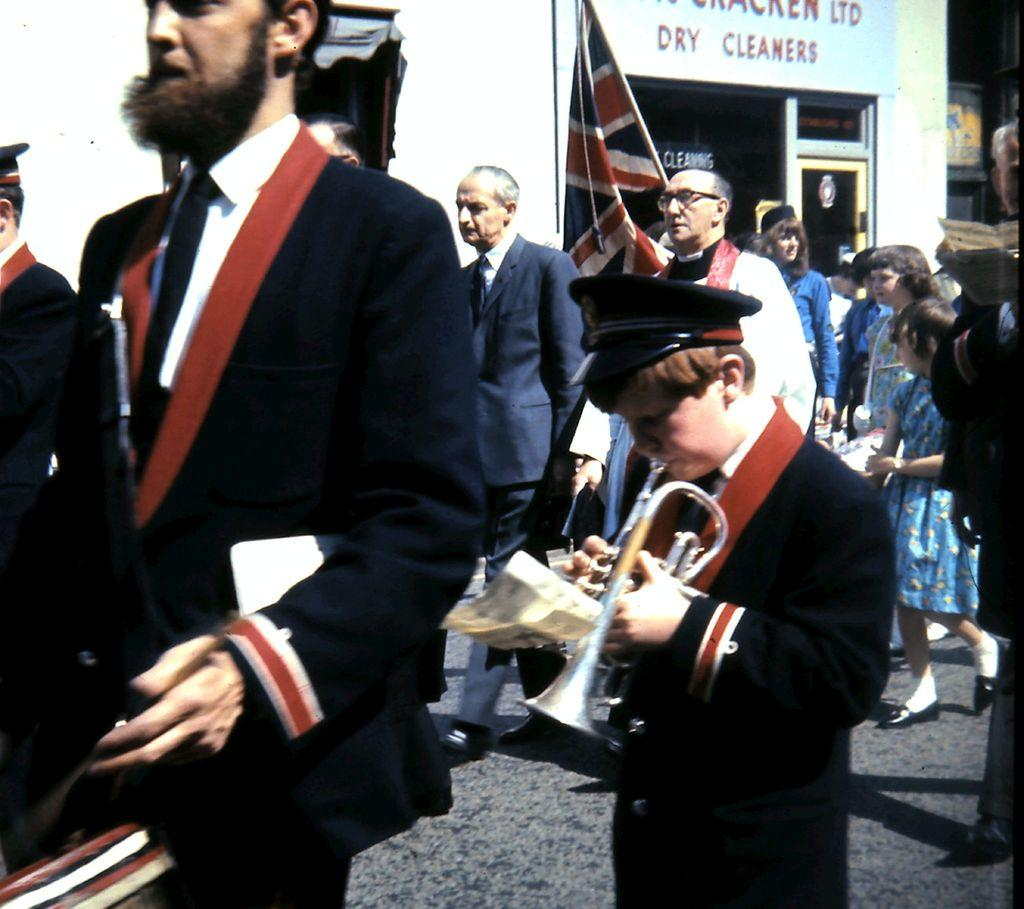How many people can be seen in the image? There are many people in the image. What are the people doing in the image? The people are walking on the road. What are the people wearing in the image? The people are wearing suits. What type of surface can be seen in the image? There is a road visible in the image. What type of beast can be seen in the image? There is no beast present in the image; it features people walking on a road. 